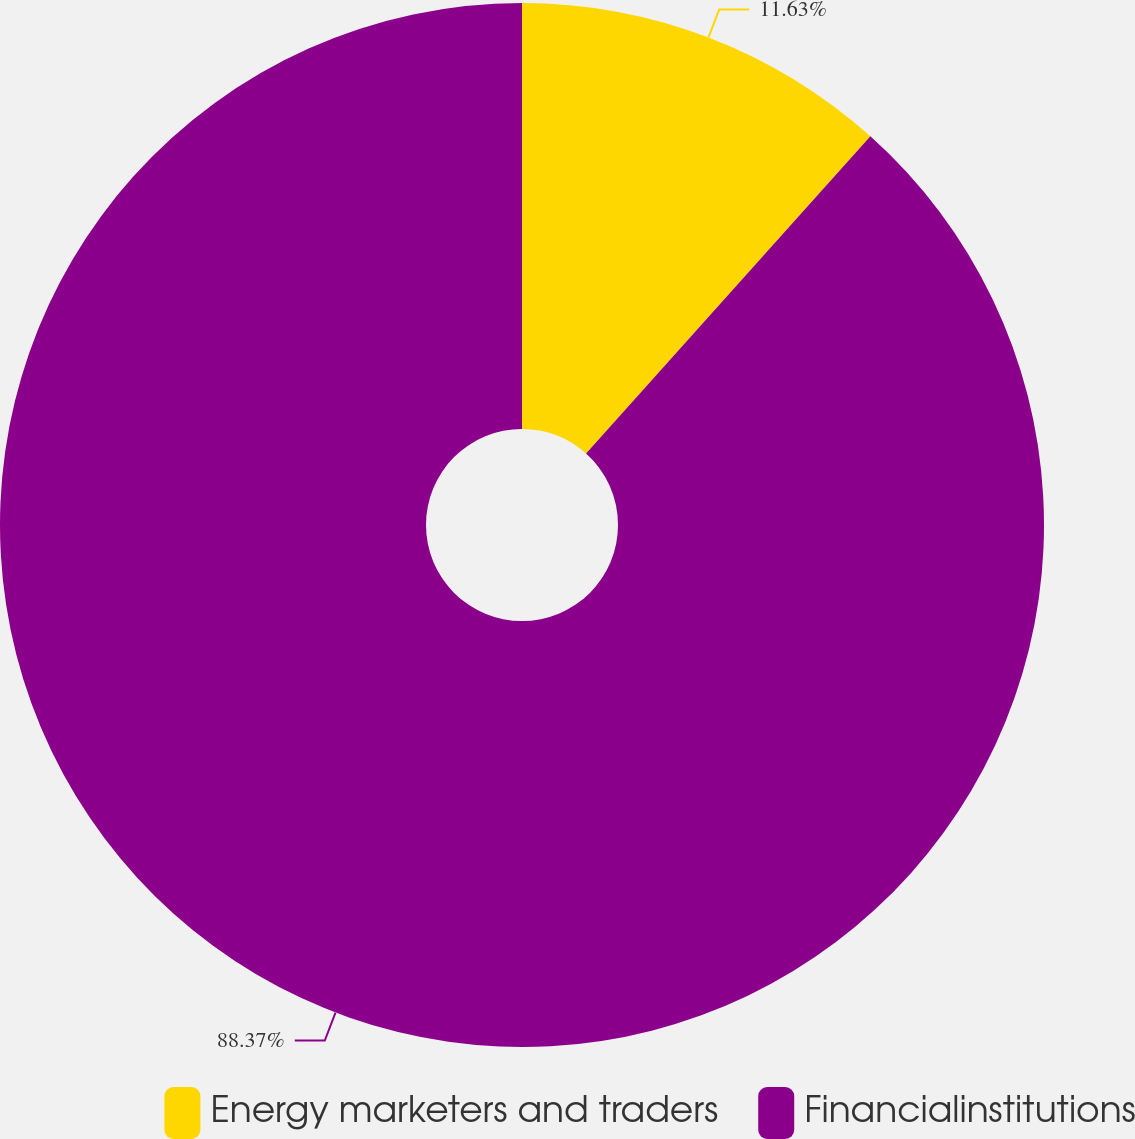<chart> <loc_0><loc_0><loc_500><loc_500><pie_chart><fcel>Energy marketers and traders<fcel>Financialinstitutions<nl><fcel>11.63%<fcel>88.37%<nl></chart> 